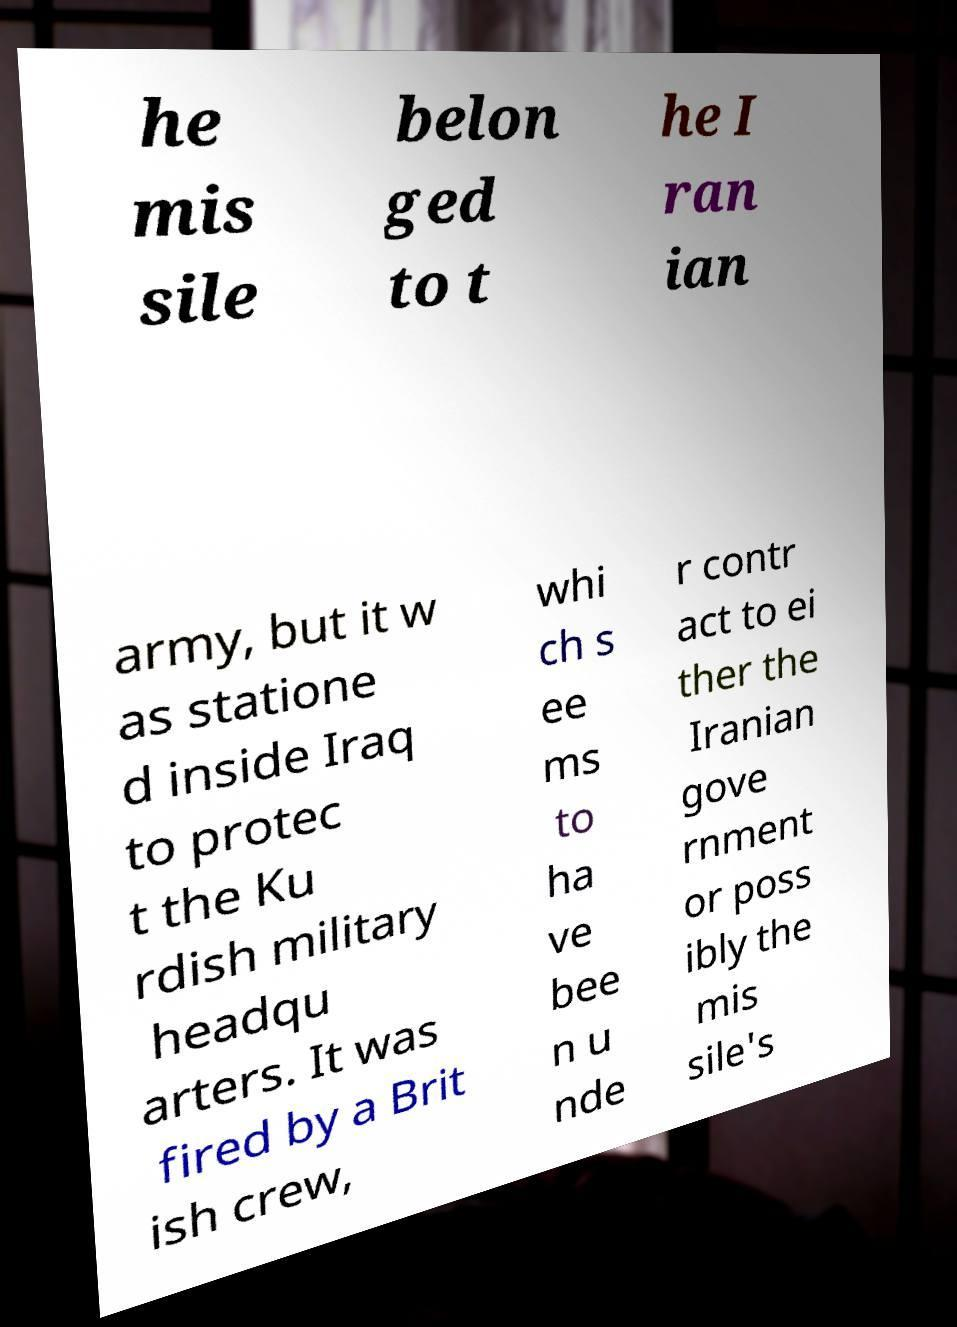Please read and relay the text visible in this image. What does it say? he mis sile belon ged to t he I ran ian army, but it w as statione d inside Iraq to protec t the Ku rdish military headqu arters. It was fired by a Brit ish crew, whi ch s ee ms to ha ve bee n u nde r contr act to ei ther the Iranian gove rnment or poss ibly the mis sile's 